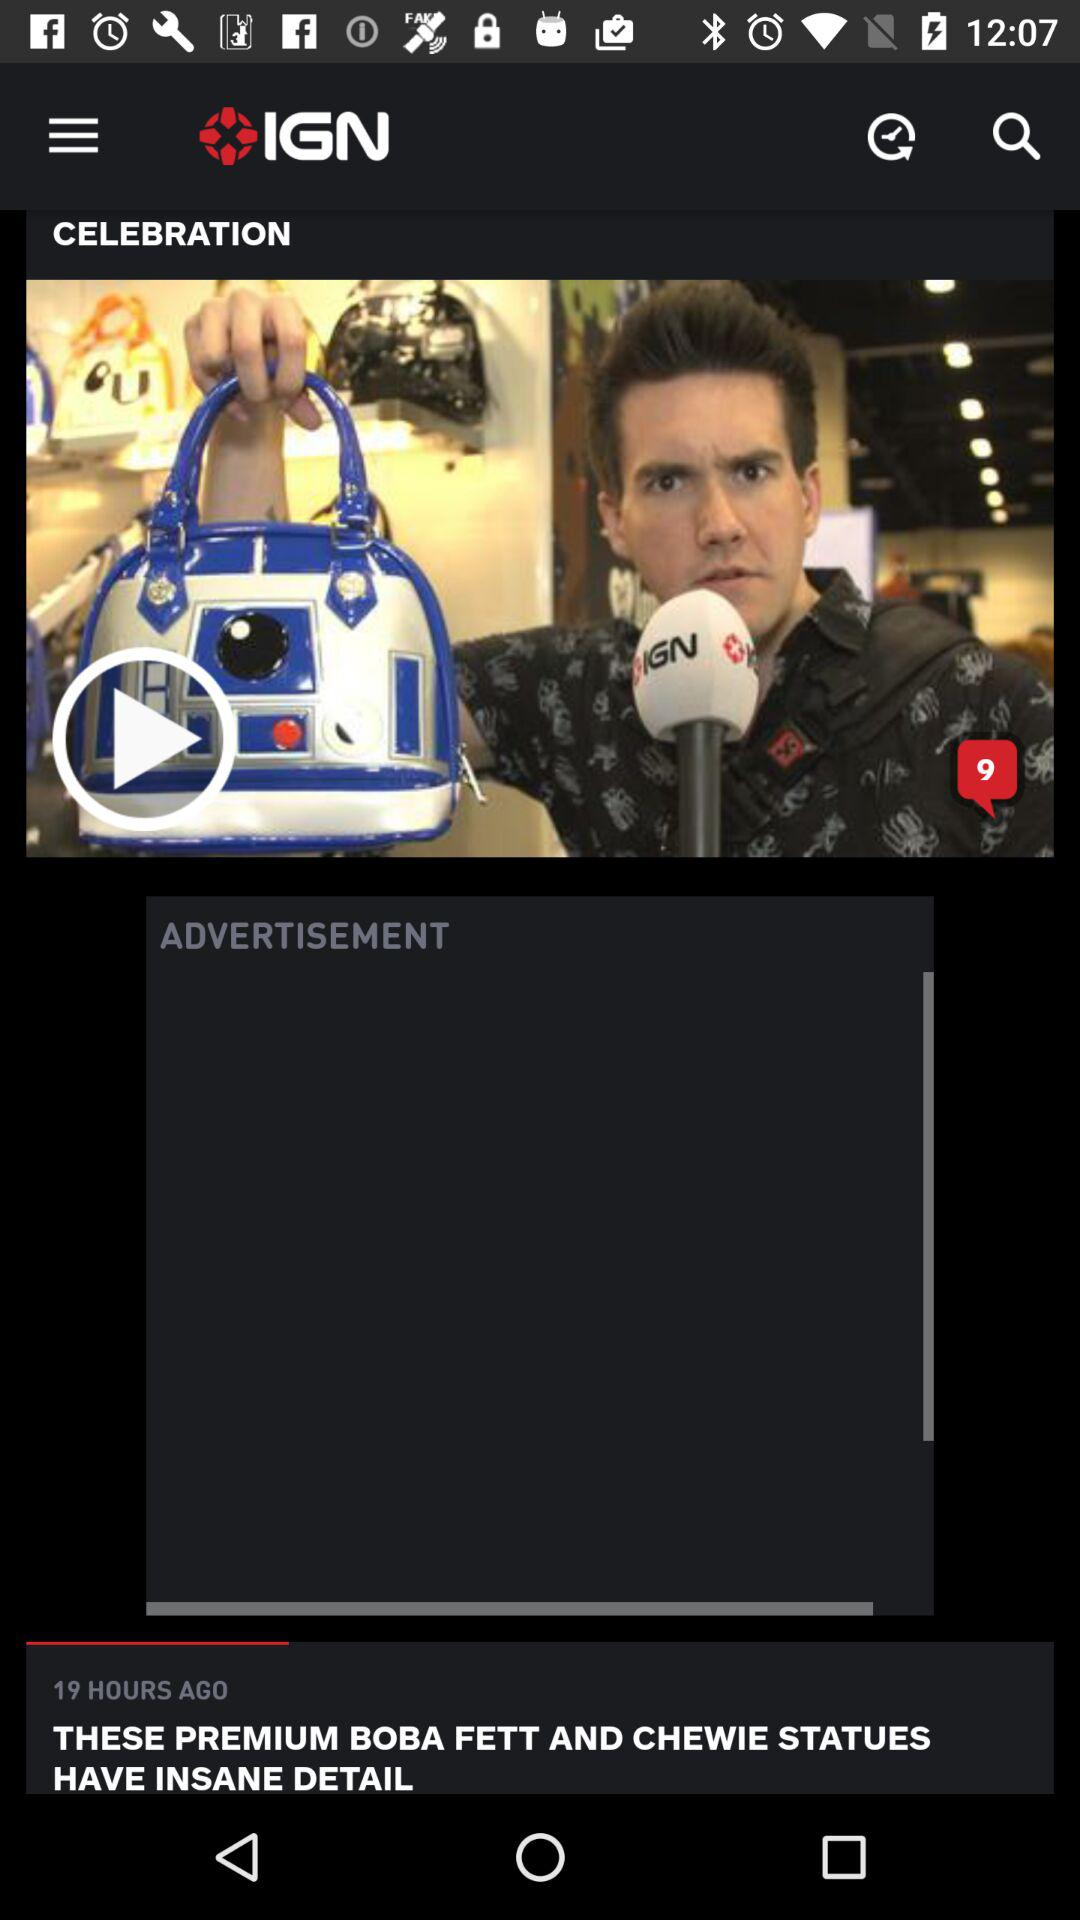How many hours ago was the advertisement posted?
Answer the question using a single word or phrase. 19 